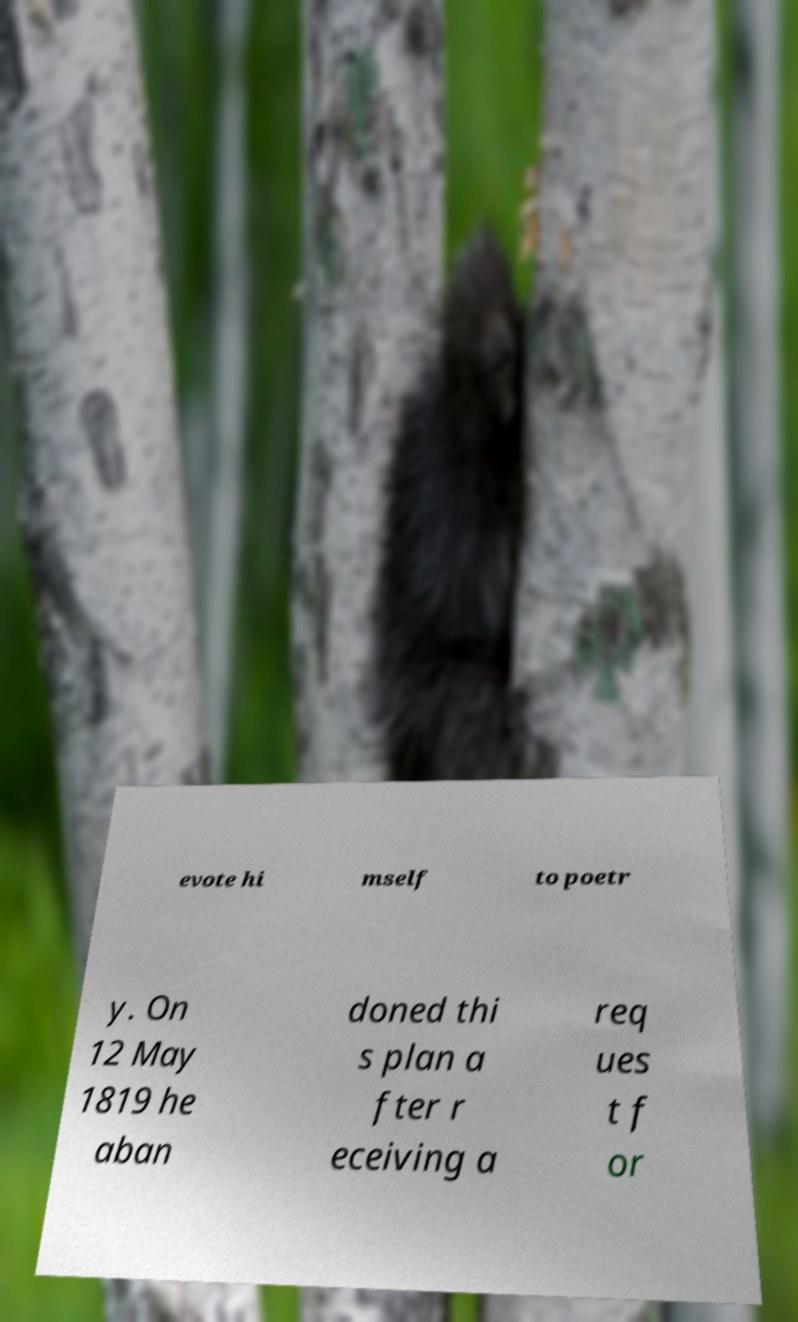For documentation purposes, I need the text within this image transcribed. Could you provide that? evote hi mself to poetr y. On 12 May 1819 he aban doned thi s plan a fter r eceiving a req ues t f or 